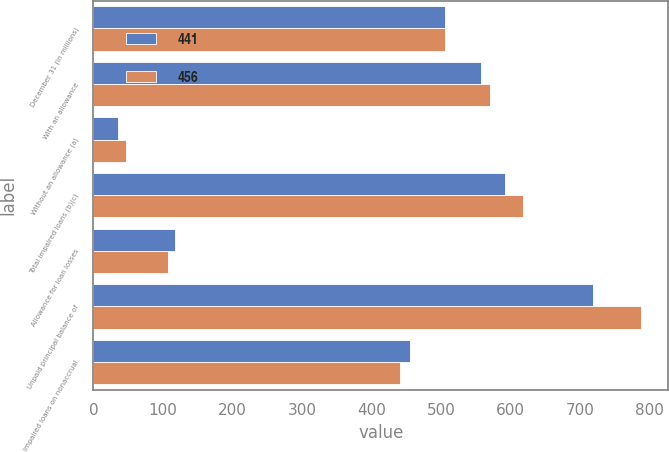<chart> <loc_0><loc_0><loc_500><loc_500><stacked_bar_chart><ecel><fcel>December 31 (in millions)<fcel>With an allowance<fcel>Without an allowance (a)<fcel>Total impaired loans (b)(c)<fcel>Allowance for loan losses<fcel>Unpaid principal balance of<fcel>Impaired loans on nonaccrual<nl><fcel>441<fcel>506.5<fcel>557<fcel>35<fcel>592<fcel>117<fcel>719<fcel>456<nl><fcel>456<fcel>506.5<fcel>571<fcel>47<fcel>618<fcel>107<fcel>788<fcel>441<nl></chart> 